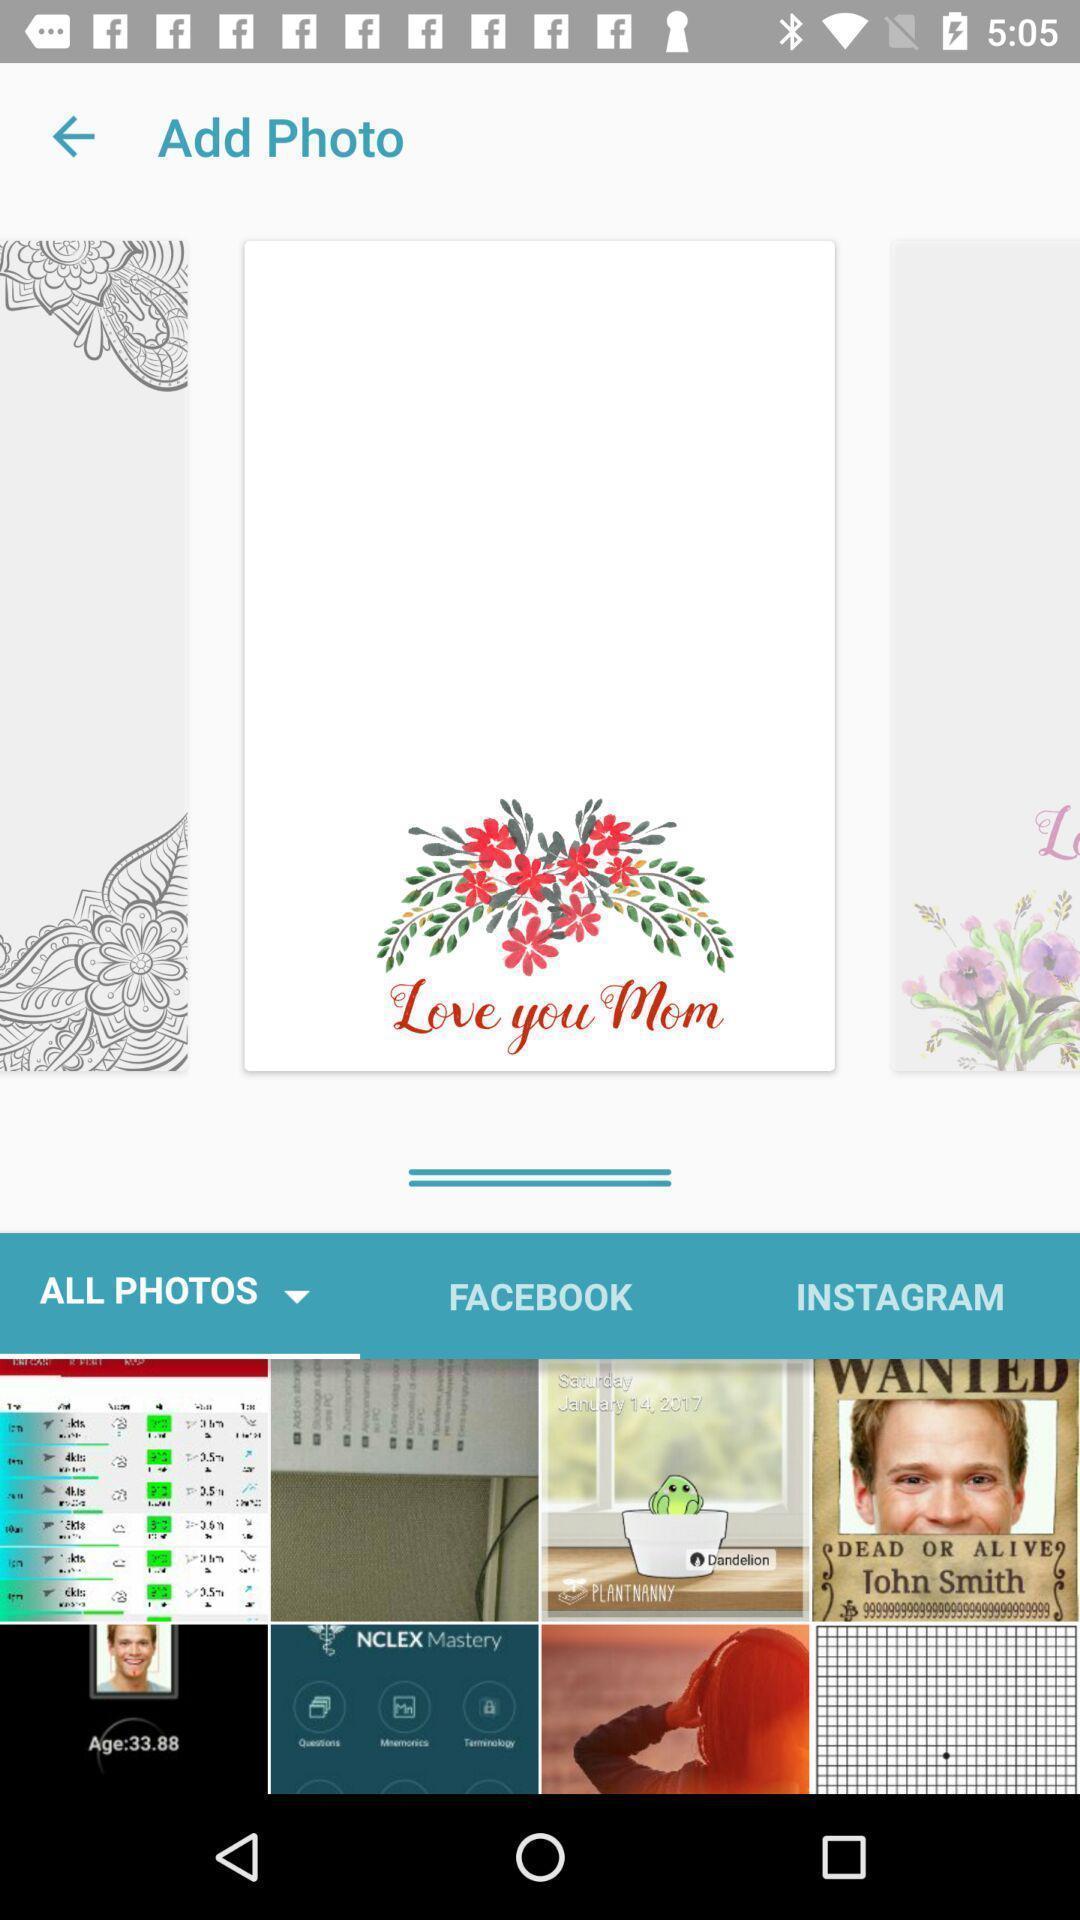Provide a description of this screenshot. Window displaying to choose photo. 